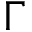Convert formula to latex. <formula><loc_0><loc_0><loc_500><loc_500>\Gamma</formula> 